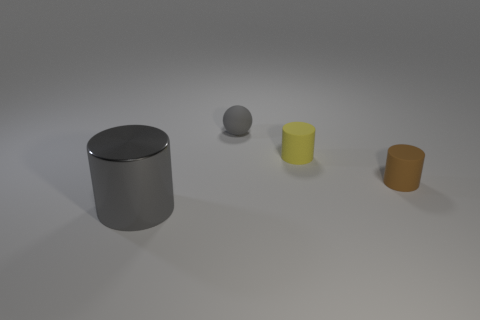The ball that is the same color as the metal cylinder is what size?
Offer a terse response. Small. What color is the sphere that is the same size as the yellow cylinder?
Provide a succinct answer. Gray. What is the shape of the tiny matte thing that is the same color as the big metal thing?
Your answer should be very brief. Sphere. Do the gray thing behind the brown thing and the yellow matte cylinder have the same size?
Keep it short and to the point. Yes. There is a big object to the left of the tiny yellow object; what is it made of?
Offer a very short reply. Metal. Are there the same number of small gray objects that are right of the yellow matte cylinder and objects in front of the large thing?
Make the answer very short. Yes. There is a large metal object that is the same shape as the brown matte object; what color is it?
Provide a succinct answer. Gray. Is there any other thing of the same color as the big cylinder?
Provide a succinct answer. Yes. What number of matte objects are either large cylinders or cylinders?
Your answer should be very brief. 2. Is the matte ball the same color as the metallic thing?
Your answer should be very brief. Yes. 